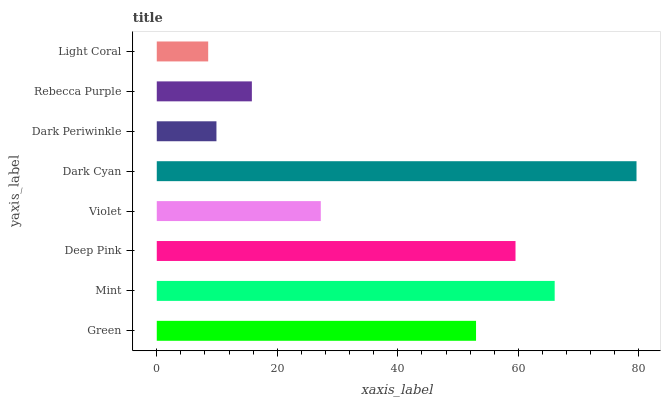Is Light Coral the minimum?
Answer yes or no. Yes. Is Dark Cyan the maximum?
Answer yes or no. Yes. Is Mint the minimum?
Answer yes or no. No. Is Mint the maximum?
Answer yes or no. No. Is Mint greater than Green?
Answer yes or no. Yes. Is Green less than Mint?
Answer yes or no. Yes. Is Green greater than Mint?
Answer yes or no. No. Is Mint less than Green?
Answer yes or no. No. Is Green the high median?
Answer yes or no. Yes. Is Violet the low median?
Answer yes or no. Yes. Is Violet the high median?
Answer yes or no. No. Is Dark Cyan the low median?
Answer yes or no. No. 